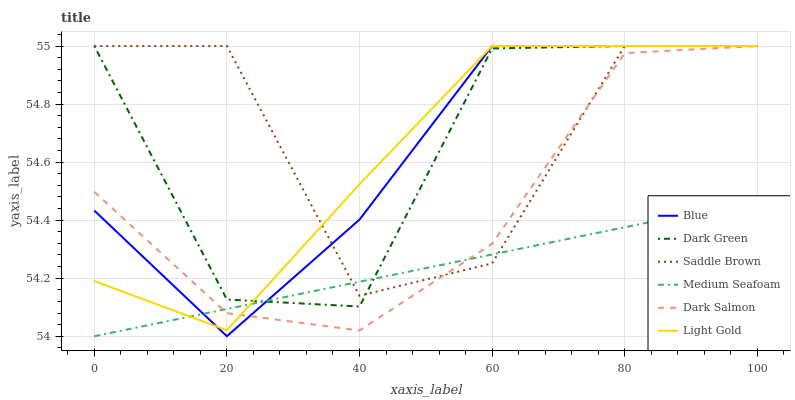Does Medium Seafoam have the minimum area under the curve?
Answer yes or no. Yes. Does Saddle Brown have the maximum area under the curve?
Answer yes or no. Yes. Does Dark Salmon have the minimum area under the curve?
Answer yes or no. No. Does Dark Salmon have the maximum area under the curve?
Answer yes or no. No. Is Medium Seafoam the smoothest?
Answer yes or no. Yes. Is Saddle Brown the roughest?
Answer yes or no. Yes. Is Dark Salmon the smoothest?
Answer yes or no. No. Is Dark Salmon the roughest?
Answer yes or no. No. Does Medium Seafoam have the lowest value?
Answer yes or no. Yes. Does Dark Salmon have the lowest value?
Answer yes or no. No. Does Dark Green have the highest value?
Answer yes or no. Yes. Does Medium Seafoam have the highest value?
Answer yes or no. No. Does Medium Seafoam intersect Light Gold?
Answer yes or no. Yes. Is Medium Seafoam less than Light Gold?
Answer yes or no. No. Is Medium Seafoam greater than Light Gold?
Answer yes or no. No. 